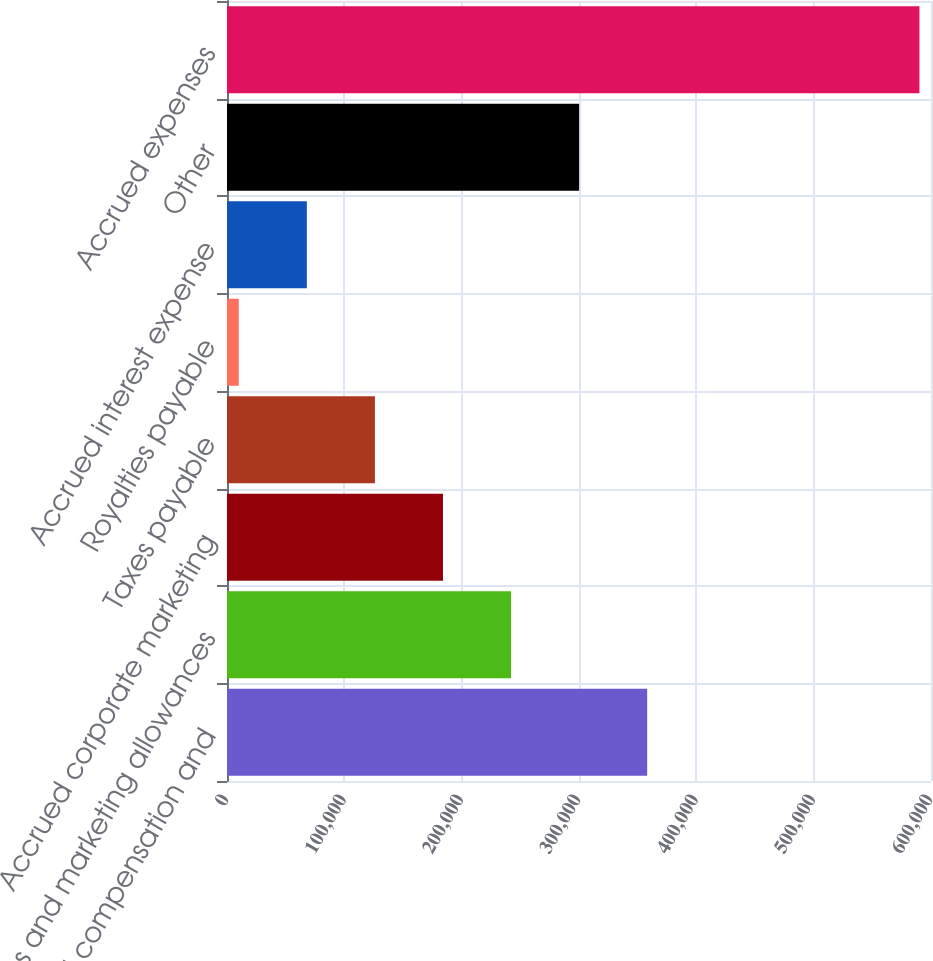Convert chart. <chart><loc_0><loc_0><loc_500><loc_500><bar_chart><fcel>Accrued compensation and<fcel>Sales and marketing allowances<fcel>Accrued corporate marketing<fcel>Taxes payable<fcel>Royalties payable<fcel>Accrued interest expense<fcel>Other<fcel>Accrued expenses<nl><fcel>358100<fcel>242080<fcel>184070<fcel>126060<fcel>10040<fcel>68050<fcel>300090<fcel>590140<nl></chart> 